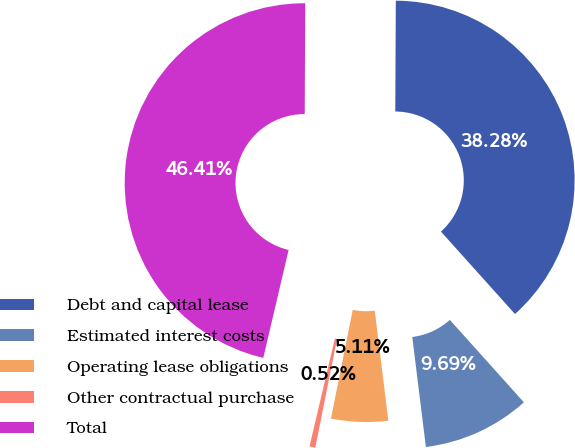<chart> <loc_0><loc_0><loc_500><loc_500><pie_chart><fcel>Debt and capital lease<fcel>Estimated interest costs<fcel>Operating lease obligations<fcel>Other contractual purchase<fcel>Total<nl><fcel>38.28%<fcel>9.69%<fcel>5.11%<fcel>0.52%<fcel>46.41%<nl></chart> 